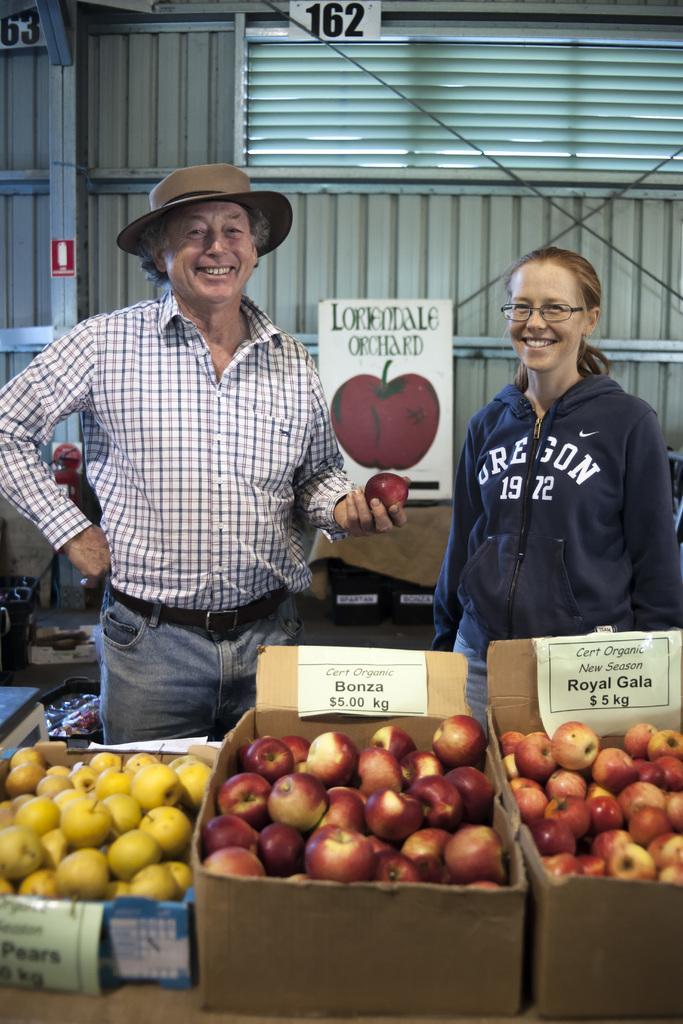In one or two sentences, can you explain what this image depicts? In this picture I can see there is a man and a woman standing, the woman is having spectacles and the man is wearing a cap. There are few fruits placed in the carton boxes. In the backdrop there is a wall and there are few numbers placed on the wall. 